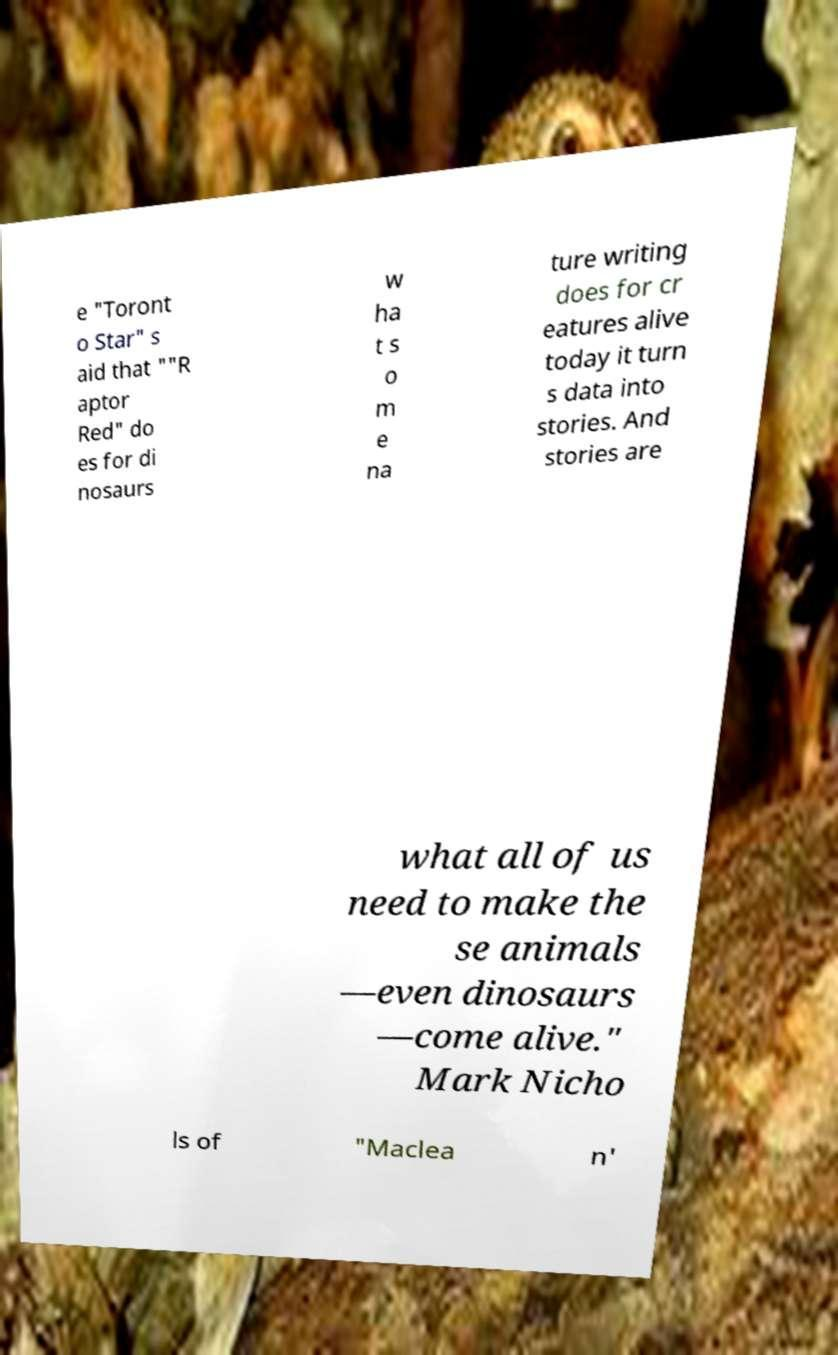Please identify and transcribe the text found in this image. e "Toront o Star" s aid that ""R aptor Red" do es for di nosaurs w ha t s o m e na ture writing does for cr eatures alive today it turn s data into stories. And stories are what all of us need to make the se animals —even dinosaurs —come alive." Mark Nicho ls of "Maclea n' 